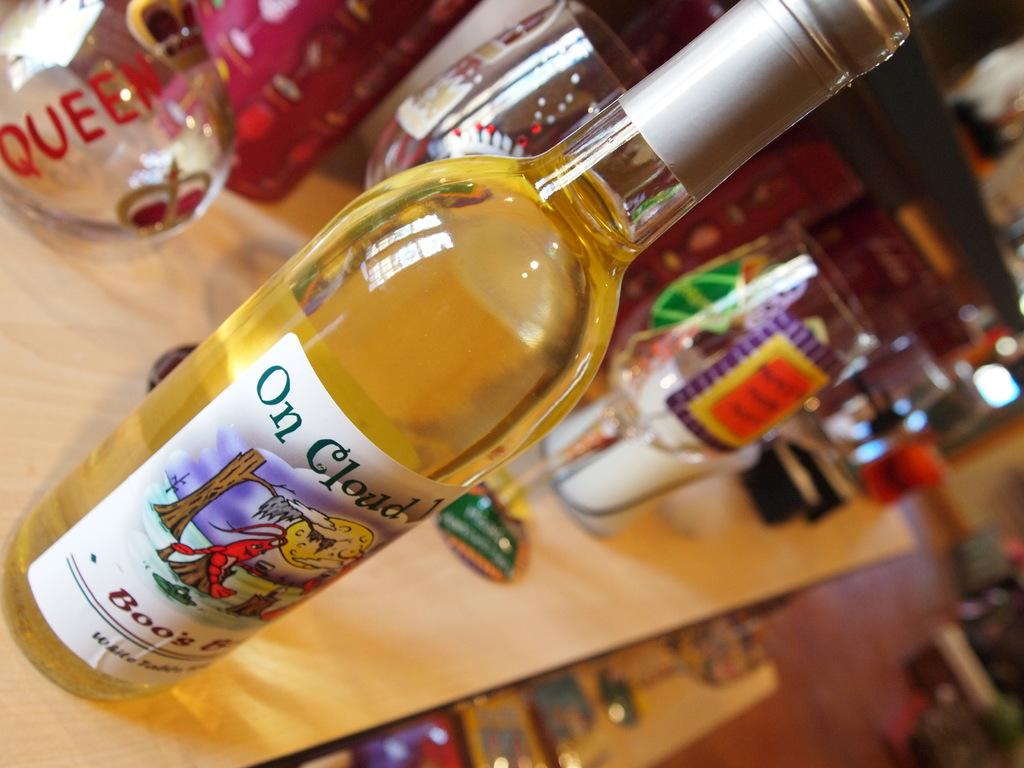Provide a one-sentence caption for the provided image. A bottle of On Cloud Wine sits on a table with a variety of glasses. 